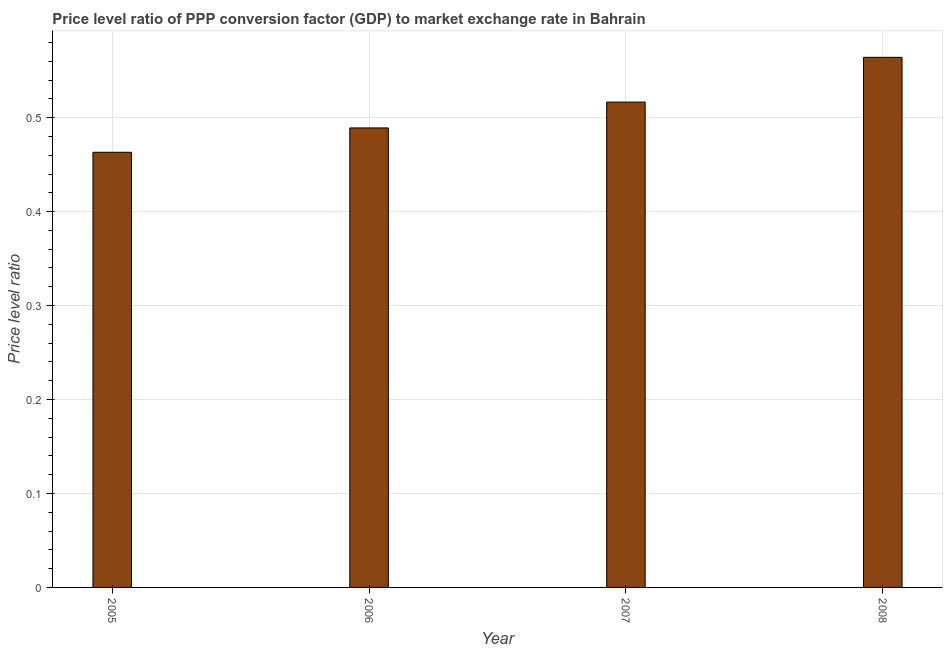Does the graph contain any zero values?
Your response must be concise. No. Does the graph contain grids?
Your answer should be very brief. Yes. What is the title of the graph?
Your answer should be compact. Price level ratio of PPP conversion factor (GDP) to market exchange rate in Bahrain. What is the label or title of the X-axis?
Your answer should be compact. Year. What is the label or title of the Y-axis?
Offer a terse response. Price level ratio. What is the price level ratio in 2007?
Give a very brief answer. 0.52. Across all years, what is the maximum price level ratio?
Your answer should be very brief. 0.56. Across all years, what is the minimum price level ratio?
Offer a terse response. 0.46. In which year was the price level ratio maximum?
Keep it short and to the point. 2008. In which year was the price level ratio minimum?
Your answer should be compact. 2005. What is the sum of the price level ratio?
Make the answer very short. 2.03. What is the difference between the price level ratio in 2006 and 2007?
Your response must be concise. -0.03. What is the average price level ratio per year?
Your answer should be compact. 0.51. What is the median price level ratio?
Ensure brevity in your answer.  0.5. What is the ratio of the price level ratio in 2006 to that in 2008?
Give a very brief answer. 0.87. Is the difference between the price level ratio in 2007 and 2008 greater than the difference between any two years?
Provide a short and direct response. No. What is the difference between the highest and the second highest price level ratio?
Provide a short and direct response. 0.05. Is the sum of the price level ratio in 2005 and 2006 greater than the maximum price level ratio across all years?
Make the answer very short. Yes. What is the difference between the highest and the lowest price level ratio?
Make the answer very short. 0.1. How many bars are there?
Provide a short and direct response. 4. Are all the bars in the graph horizontal?
Give a very brief answer. No. Are the values on the major ticks of Y-axis written in scientific E-notation?
Your answer should be very brief. No. What is the Price level ratio in 2005?
Provide a succinct answer. 0.46. What is the Price level ratio of 2006?
Offer a terse response. 0.49. What is the Price level ratio in 2007?
Provide a short and direct response. 0.52. What is the Price level ratio of 2008?
Offer a very short reply. 0.56. What is the difference between the Price level ratio in 2005 and 2006?
Offer a very short reply. -0.03. What is the difference between the Price level ratio in 2005 and 2007?
Your answer should be compact. -0.05. What is the difference between the Price level ratio in 2005 and 2008?
Offer a very short reply. -0.1. What is the difference between the Price level ratio in 2006 and 2007?
Provide a short and direct response. -0.03. What is the difference between the Price level ratio in 2006 and 2008?
Give a very brief answer. -0.08. What is the difference between the Price level ratio in 2007 and 2008?
Make the answer very short. -0.05. What is the ratio of the Price level ratio in 2005 to that in 2006?
Your response must be concise. 0.95. What is the ratio of the Price level ratio in 2005 to that in 2007?
Keep it short and to the point. 0.9. What is the ratio of the Price level ratio in 2005 to that in 2008?
Your response must be concise. 0.82. What is the ratio of the Price level ratio in 2006 to that in 2007?
Your answer should be compact. 0.95. What is the ratio of the Price level ratio in 2006 to that in 2008?
Your response must be concise. 0.87. What is the ratio of the Price level ratio in 2007 to that in 2008?
Keep it short and to the point. 0.92. 